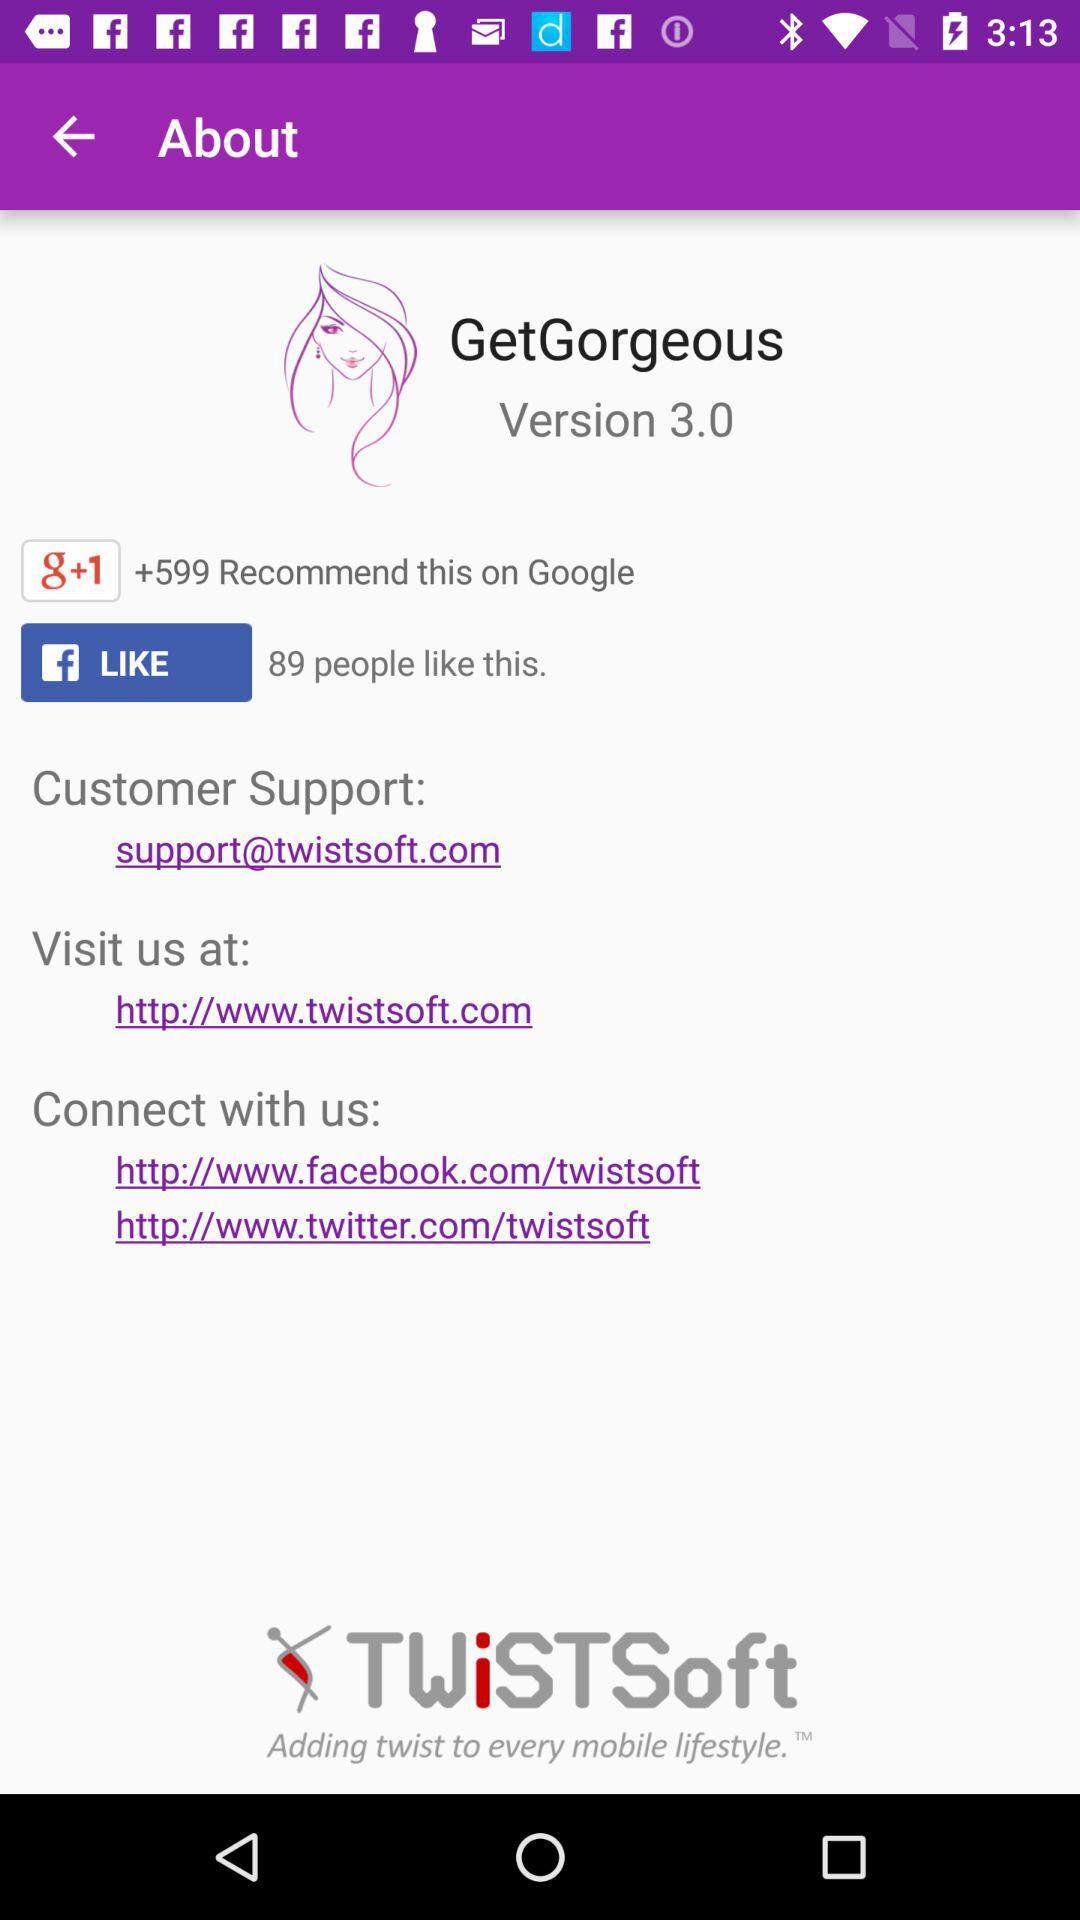What is the email address for customer support? The email address for customer support is support@twistsoft.com. 